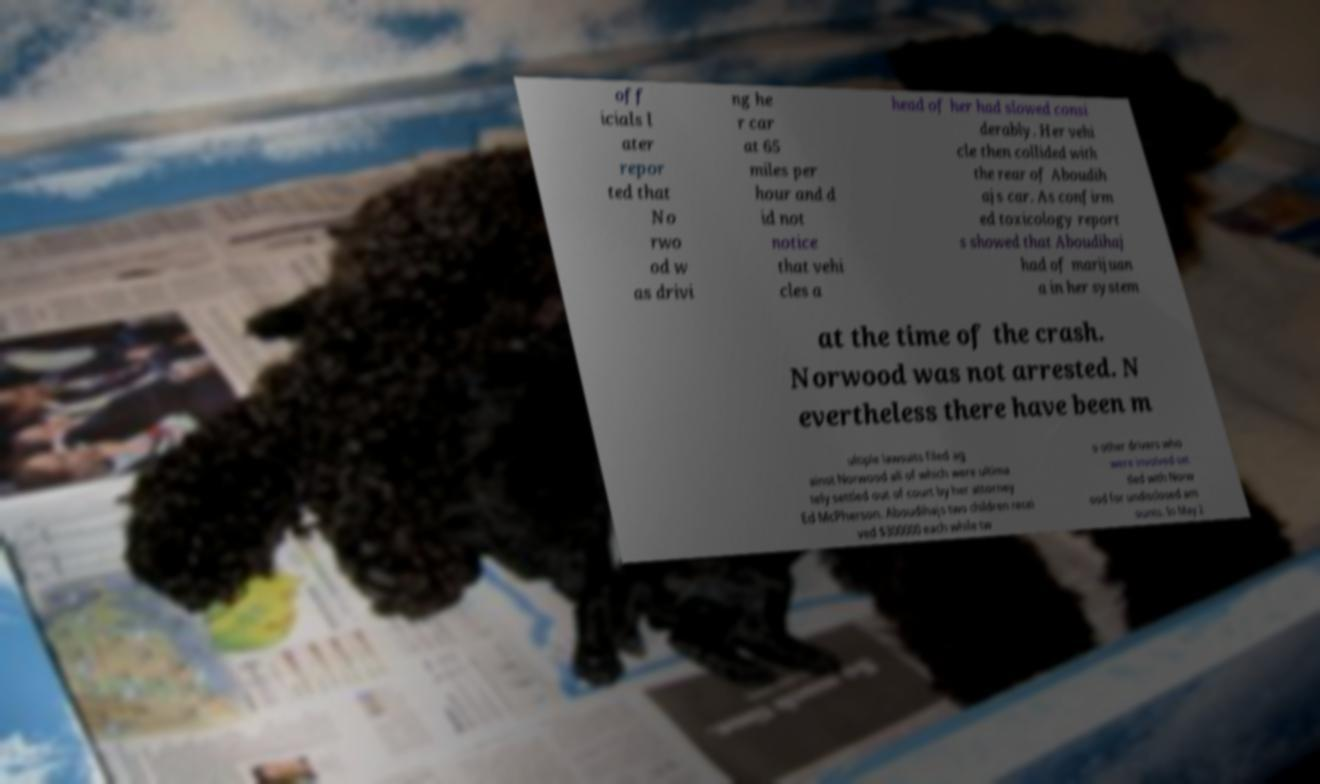Could you extract and type out the text from this image? off icials l ater repor ted that No rwo od w as drivi ng he r car at 65 miles per hour and d id not notice that vehi cles a head of her had slowed consi derably. Her vehi cle then collided with the rear of Aboudih ajs car. As confirm ed toxicology report s showed that Aboudihaj had of marijuan a in her system at the time of the crash. Norwood was not arrested. N evertheless there have been m ultiple lawsuits filed ag ainst Norwood all of which were ultima tely settled out of court by her attorney Ed McPherson. Aboudihajs two children recei ved $300000 each while tw o other drivers who were involved set tled with Norw ood for undisclosed am ounts. In May 2 